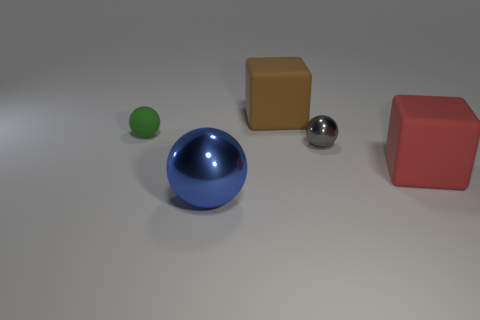There is a matte block that is on the left side of the gray shiny object; is it the same color as the matte ball?
Offer a terse response. No. Are there any other yellow balls made of the same material as the big ball?
Your answer should be very brief. No. Are there fewer big blue metal things that are in front of the small green matte thing than big yellow matte cubes?
Provide a short and direct response. No. Is the size of the cube behind the red matte block the same as the gray metallic object?
Provide a succinct answer. No. What number of tiny rubber things have the same shape as the gray metallic object?
Provide a succinct answer. 1. What is the size of the blue ball that is the same material as the tiny gray object?
Ensure brevity in your answer.  Large. Are there the same number of blue shiny spheres on the right side of the brown thing and objects?
Make the answer very short. No. Is the color of the small matte sphere the same as the large sphere?
Your answer should be very brief. No. Do the rubber thing in front of the tiny metal object and the gray metallic object that is on the right side of the brown block have the same shape?
Ensure brevity in your answer.  No. There is a gray object that is the same shape as the green thing; what material is it?
Your answer should be compact. Metal. 